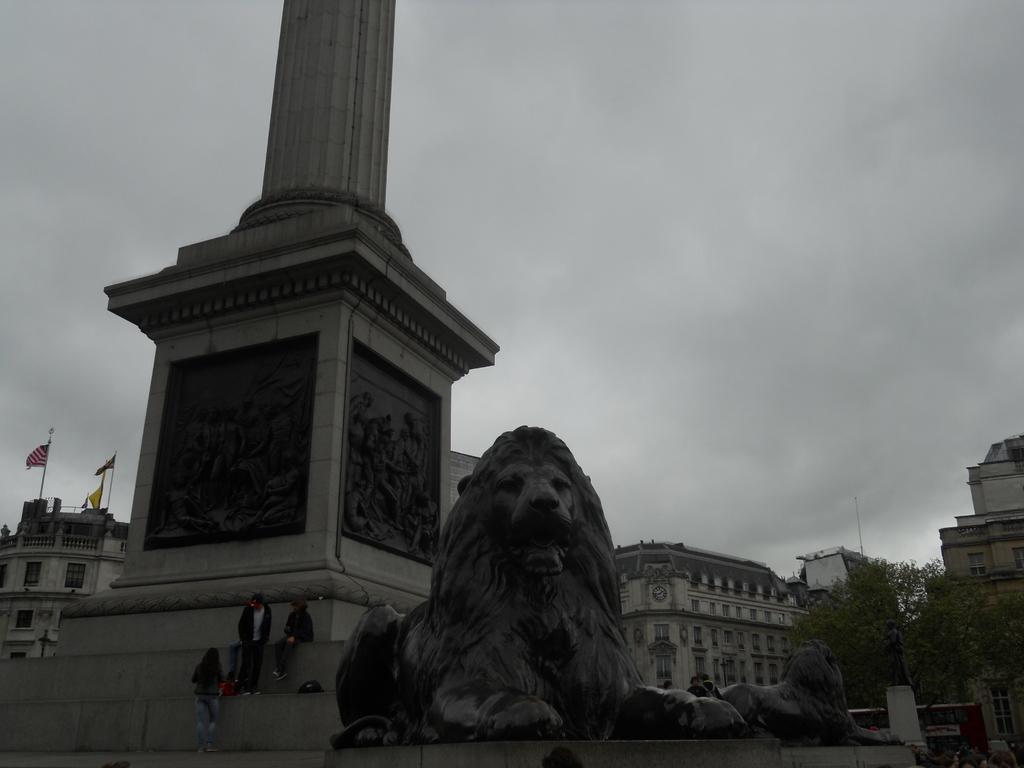Could you give a brief overview of what you see in this image? Front portion of the image we can see pillar, people, statues and things. Background portion of the image we can see a cloudy sky, flags, buildings, statue and tree.  